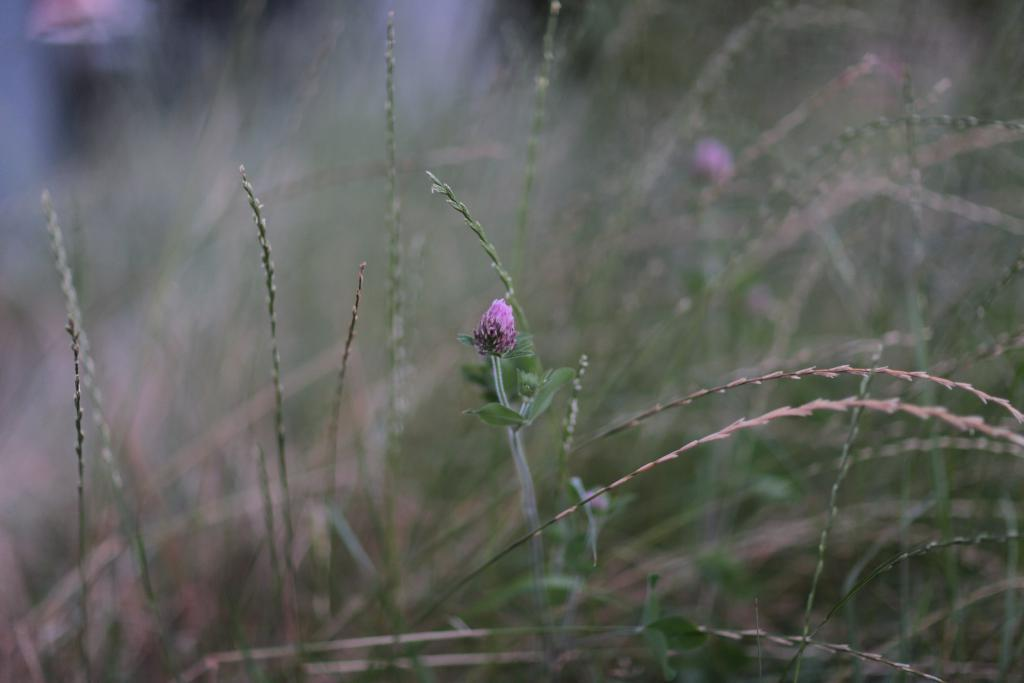What types of living organisms can be seen in the image? Plants and flowers are visible in the image. Can you describe the background of the image? The background of the image is blurry. What type of pickle can be seen growing among the plants in the image? There is no pickle present in the image; it features plants and flowers. 